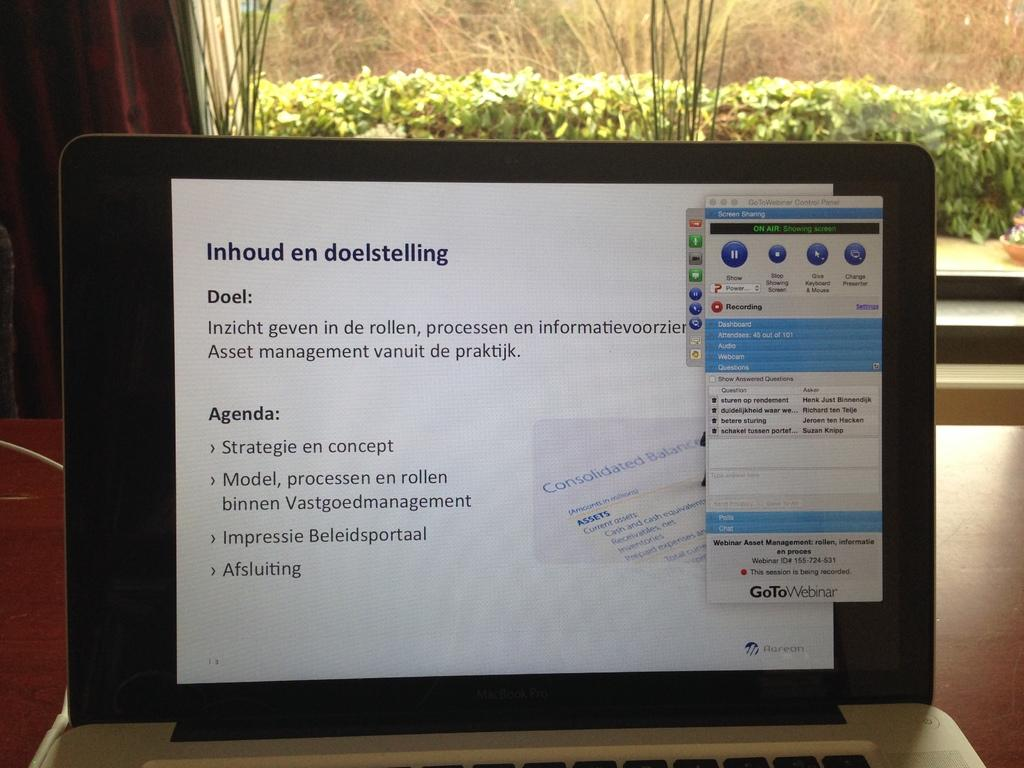<image>
Relay a brief, clear account of the picture shown. Inhoud en doelstelling is displayed at the top of the screen of this laptop. 